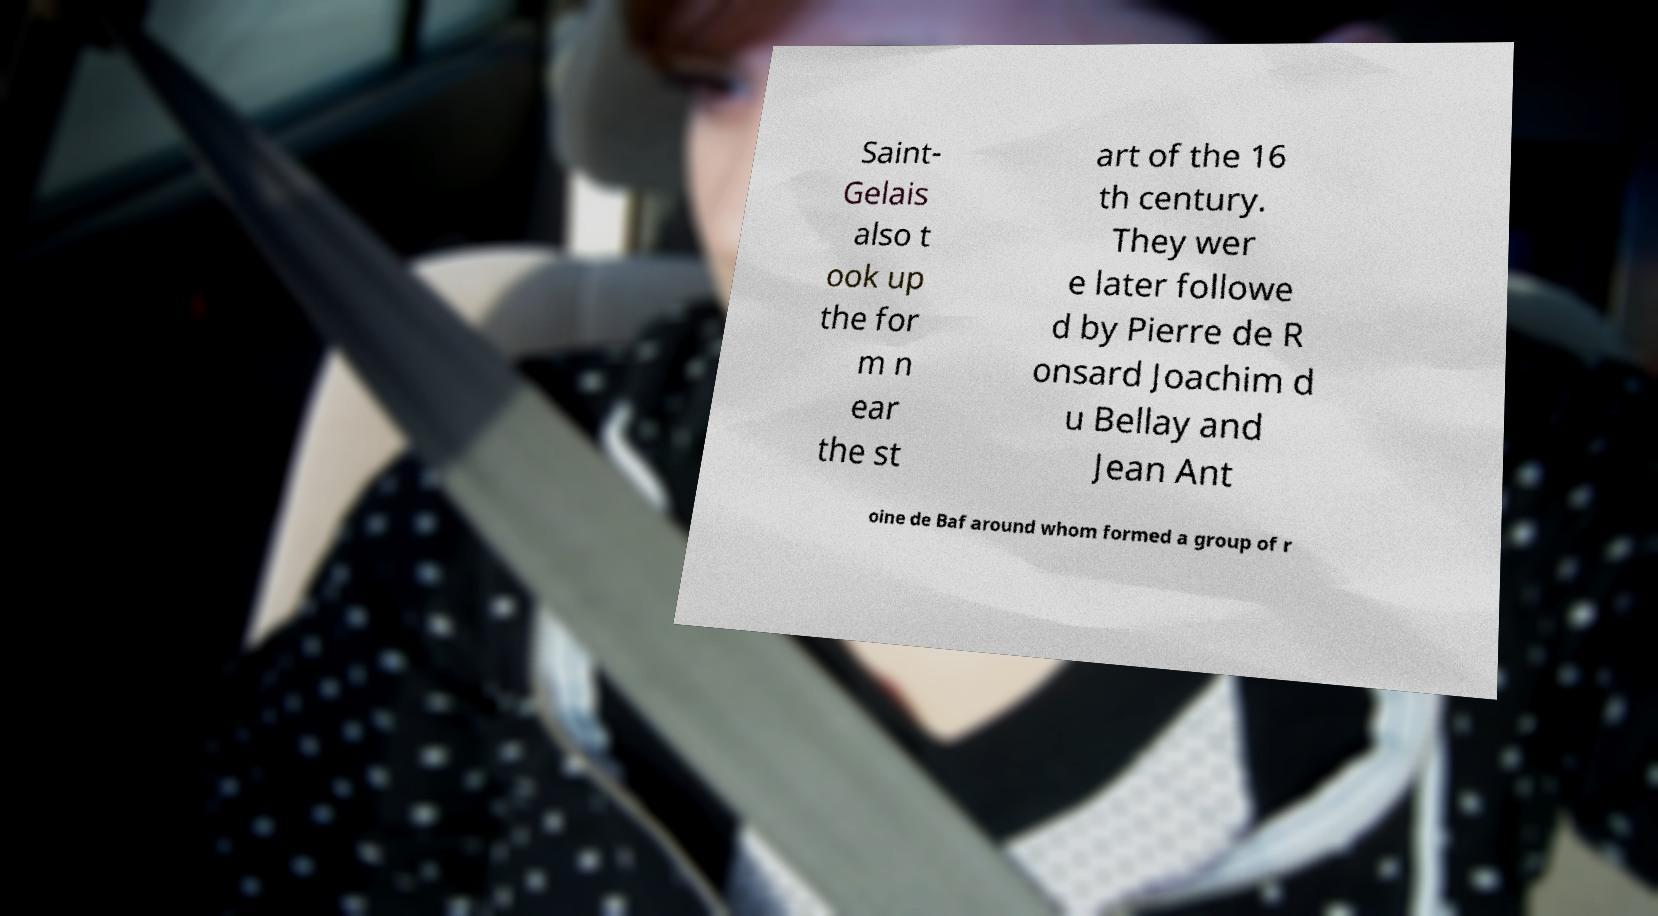Please identify and transcribe the text found in this image. Saint- Gelais also t ook up the for m n ear the st art of the 16 th century. They wer e later followe d by Pierre de R onsard Joachim d u Bellay and Jean Ant oine de Baf around whom formed a group of r 